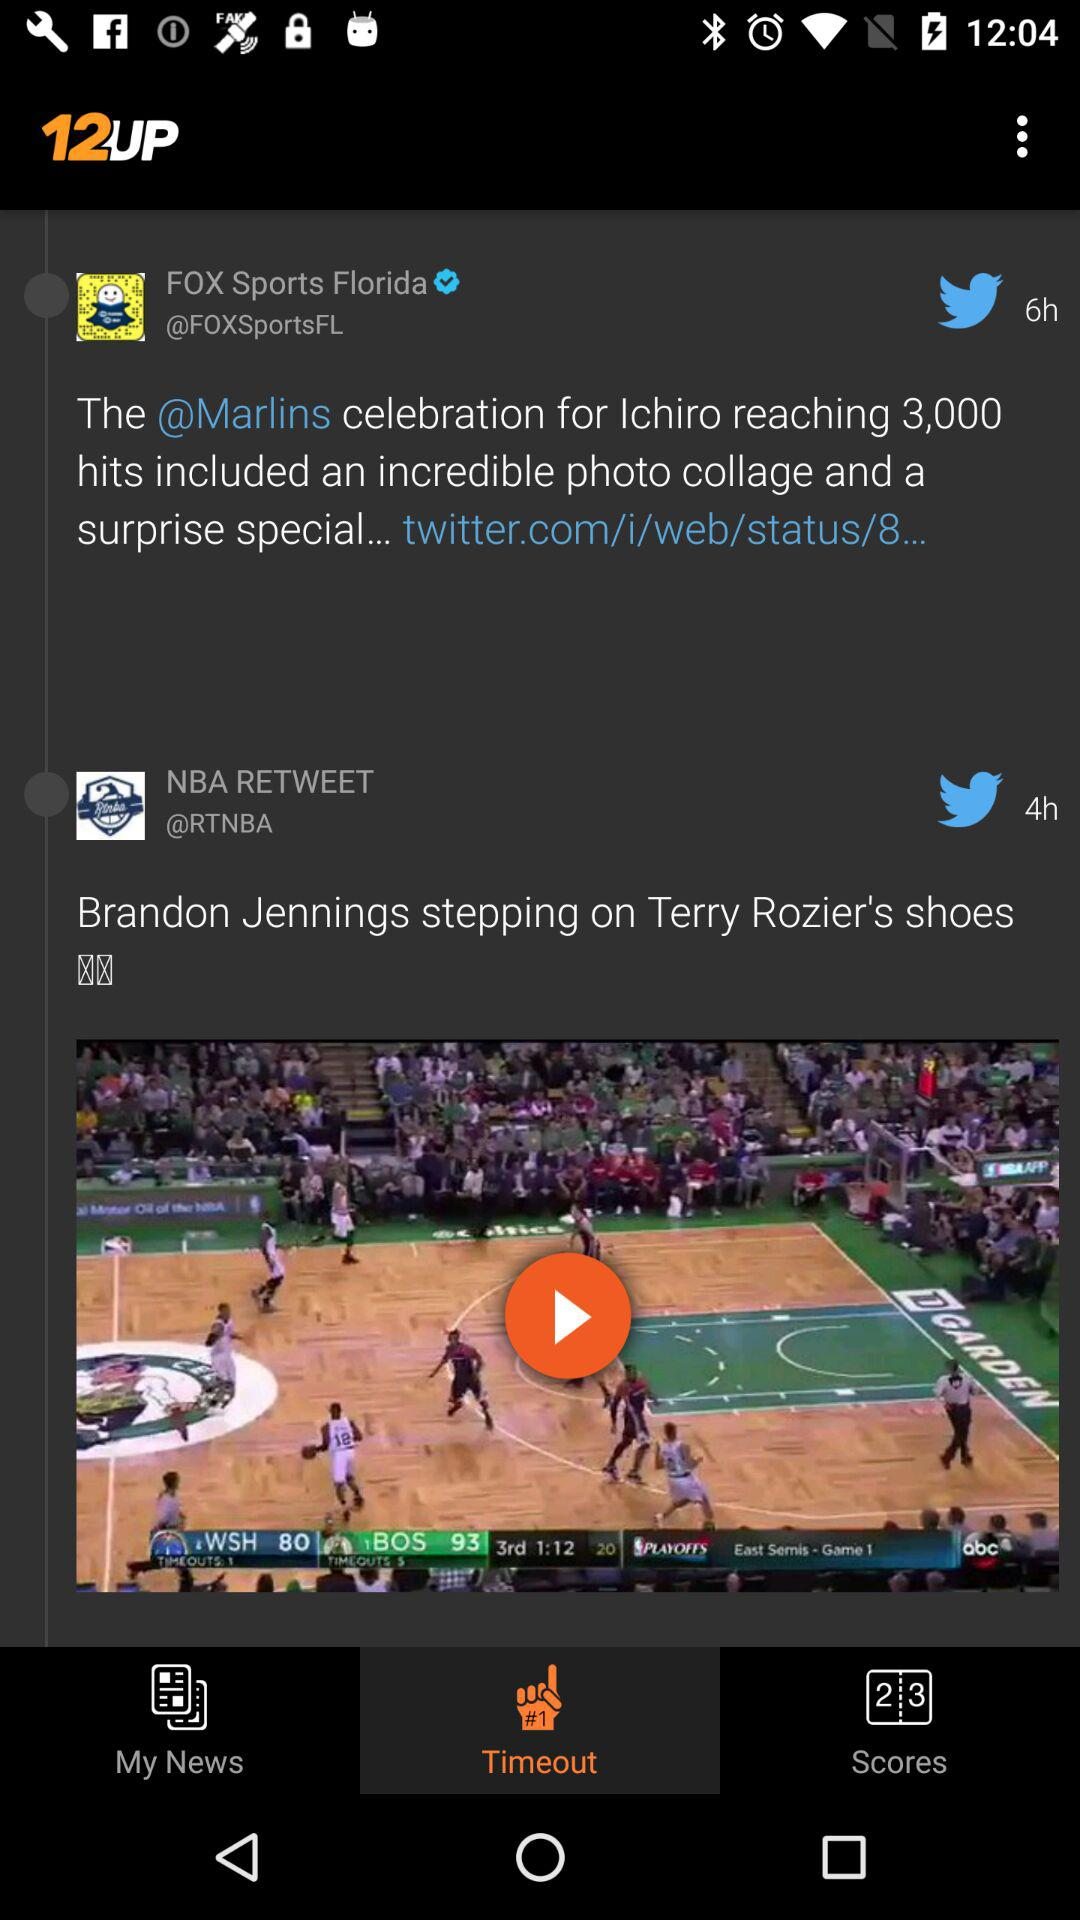How many more checkmarks are there on the Fox Sports Florida tweet compared to the NBA retweet?
Answer the question using a single word or phrase. 1 